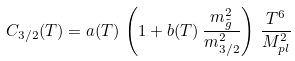Convert formula to latex. <formula><loc_0><loc_0><loc_500><loc_500>C _ { 3 / 2 } ( T ) = a ( T ) \, \left ( 1 + b ( T ) \, \frac { m _ { \tilde { g } } ^ { 2 } } { m _ { 3 / 2 } ^ { 2 } } \right ) \, \frac { T ^ { 6 } } { M _ { p l } ^ { 2 } }</formula> 